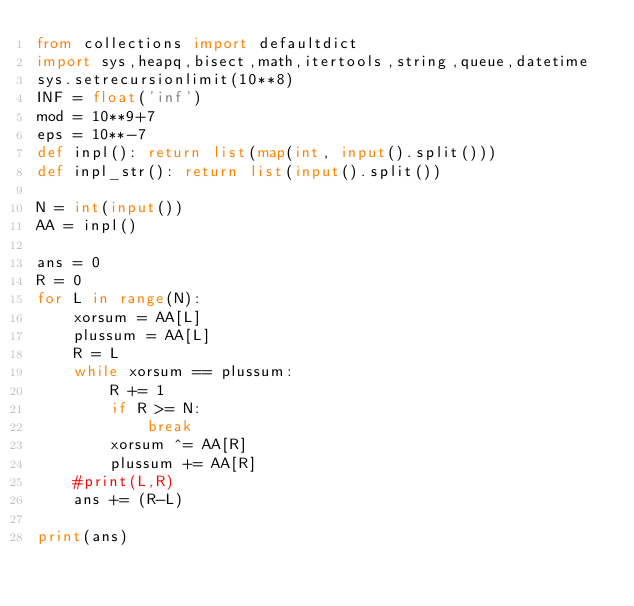<code> <loc_0><loc_0><loc_500><loc_500><_Python_>from collections import defaultdict
import sys,heapq,bisect,math,itertools,string,queue,datetime
sys.setrecursionlimit(10**8)
INF = float('inf')
mod = 10**9+7
eps = 10**-7
def inpl(): return list(map(int, input().split()))
def inpl_str(): return list(input().split())

N = int(input())
AA = inpl()

ans = 0
R = 0
for L in range(N):
    xorsum = AA[L]
    plussum = AA[L]
    R = L
    while xorsum == plussum:
        R += 1
        if R >= N:
            break
        xorsum ^= AA[R]
        plussum += AA[R]
    #print(L,R)
    ans += (R-L)

print(ans)
</code> 